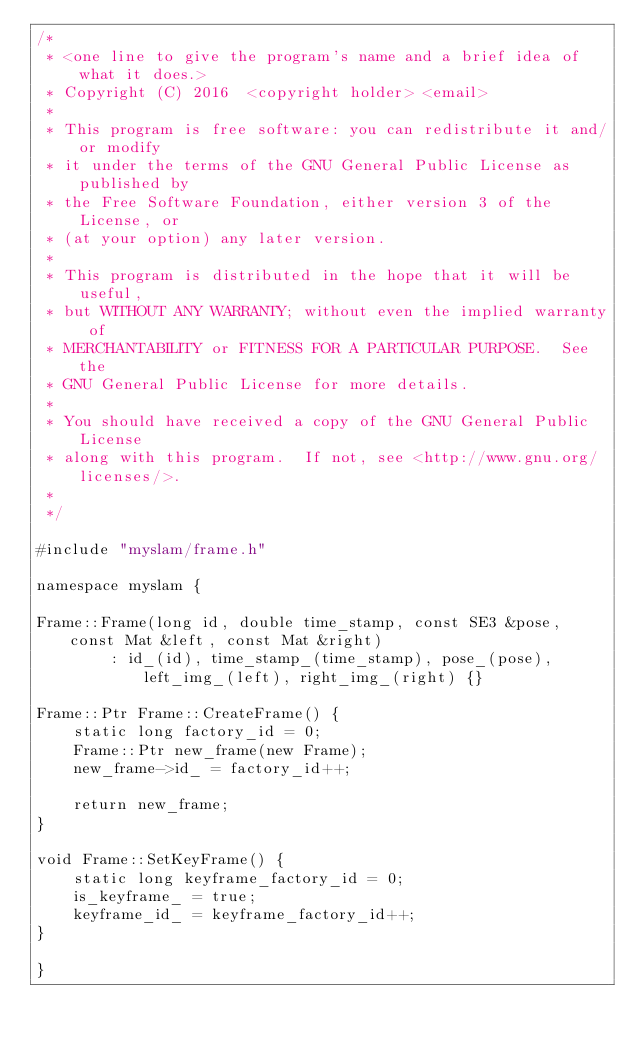<code> <loc_0><loc_0><loc_500><loc_500><_C++_>/*
 * <one line to give the program's name and a brief idea of what it does.>
 * Copyright (C) 2016  <copyright holder> <email>
 *
 * This program is free software: you can redistribute it and/or modify
 * it under the terms of the GNU General Public License as published by
 * the Free Software Foundation, either version 3 of the License, or
 * (at your option) any later version.
 *
 * This program is distributed in the hope that it will be useful,
 * but WITHOUT ANY WARRANTY; without even the implied warranty of
 * MERCHANTABILITY or FITNESS FOR A PARTICULAR PURPOSE.  See the
 * GNU General Public License for more details.
 *
 * You should have received a copy of the GNU General Public License
 * along with this program.  If not, see <http://www.gnu.org/licenses/>.
 *
 */

#include "myslam/frame.h"

namespace myslam {

Frame::Frame(long id, double time_stamp, const SE3 &pose, const Mat &left, const Mat &right)
        : id_(id), time_stamp_(time_stamp), pose_(pose), left_img_(left), right_img_(right) {}

Frame::Ptr Frame::CreateFrame() {
    static long factory_id = 0;
    Frame::Ptr new_frame(new Frame);
    new_frame->id_ = factory_id++;
    
    return new_frame;
}

void Frame::SetKeyFrame() {
    static long keyframe_factory_id = 0;
    is_keyframe_ = true;
    keyframe_id_ = keyframe_factory_id++;
}

}
</code> 